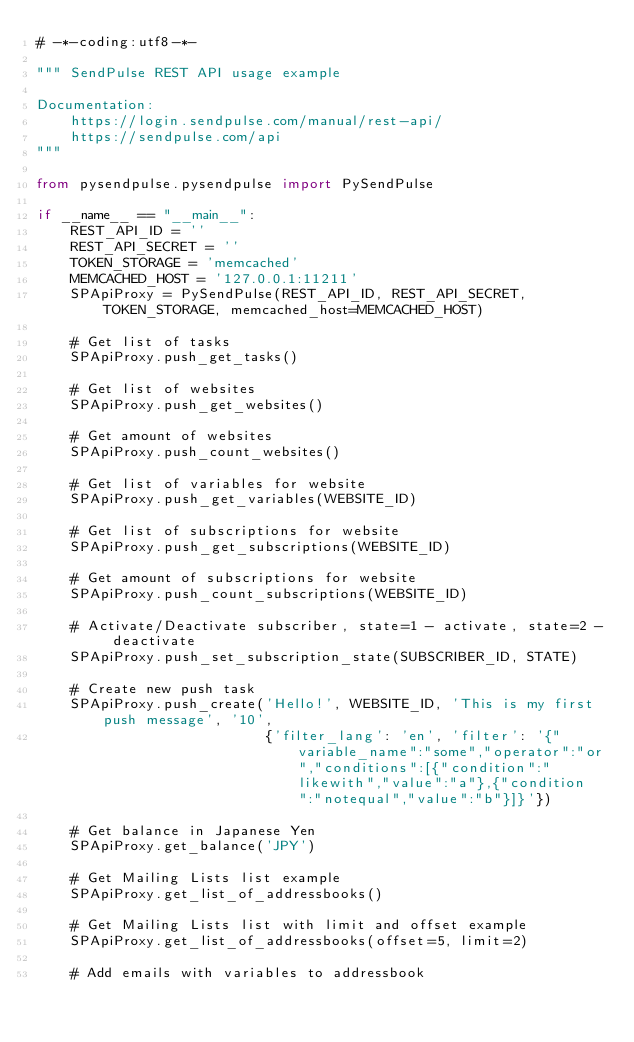Convert code to text. <code><loc_0><loc_0><loc_500><loc_500><_Python_># -*-coding:utf8-*-

""" SendPulse REST API usage example

Documentation:
    https://login.sendpulse.com/manual/rest-api/
    https://sendpulse.com/api
"""

from pysendpulse.pysendpulse import PySendPulse

if __name__ == "__main__":
    REST_API_ID = ''
    REST_API_SECRET = ''
    TOKEN_STORAGE = 'memcached'
    MEMCACHED_HOST = '127.0.0.1:11211'
    SPApiProxy = PySendPulse(REST_API_ID, REST_API_SECRET, TOKEN_STORAGE, memcached_host=MEMCACHED_HOST)

    # Get list of tasks
    SPApiProxy.push_get_tasks()

    # Get list of websites
    SPApiProxy.push_get_websites()

    # Get amount of websites
    SPApiProxy.push_count_websites()

    # Get list of variables for website
    SPApiProxy.push_get_variables(WEBSITE_ID)

    # Get list of subscriptions for website
    SPApiProxy.push_get_subscriptions(WEBSITE_ID)

    # Get amount of subscriptions for website
    SPApiProxy.push_count_subscriptions(WEBSITE_ID)

    # Activate/Deactivate subscriber, state=1 - activate, state=2 - deactivate
    SPApiProxy.push_set_subscription_state(SUBSCRIBER_ID, STATE)

    # Create new push task
    SPApiProxy.push_create('Hello!', WEBSITE_ID, 'This is my first push message', '10',
                           {'filter_lang': 'en', 'filter': '{"variable_name":"some","operator":"or","conditions":[{"condition":"likewith","value":"a"},{"condition":"notequal","value":"b"}]}'})

    # Get balance in Japanese Yen
    SPApiProxy.get_balance('JPY')

    # Get Mailing Lists list example
    SPApiProxy.get_list_of_addressbooks()

    # Get Mailing Lists list with limit and offset example
    SPApiProxy.get_list_of_addressbooks(offset=5, limit=2)

    # Add emails with variables to addressbook</code> 